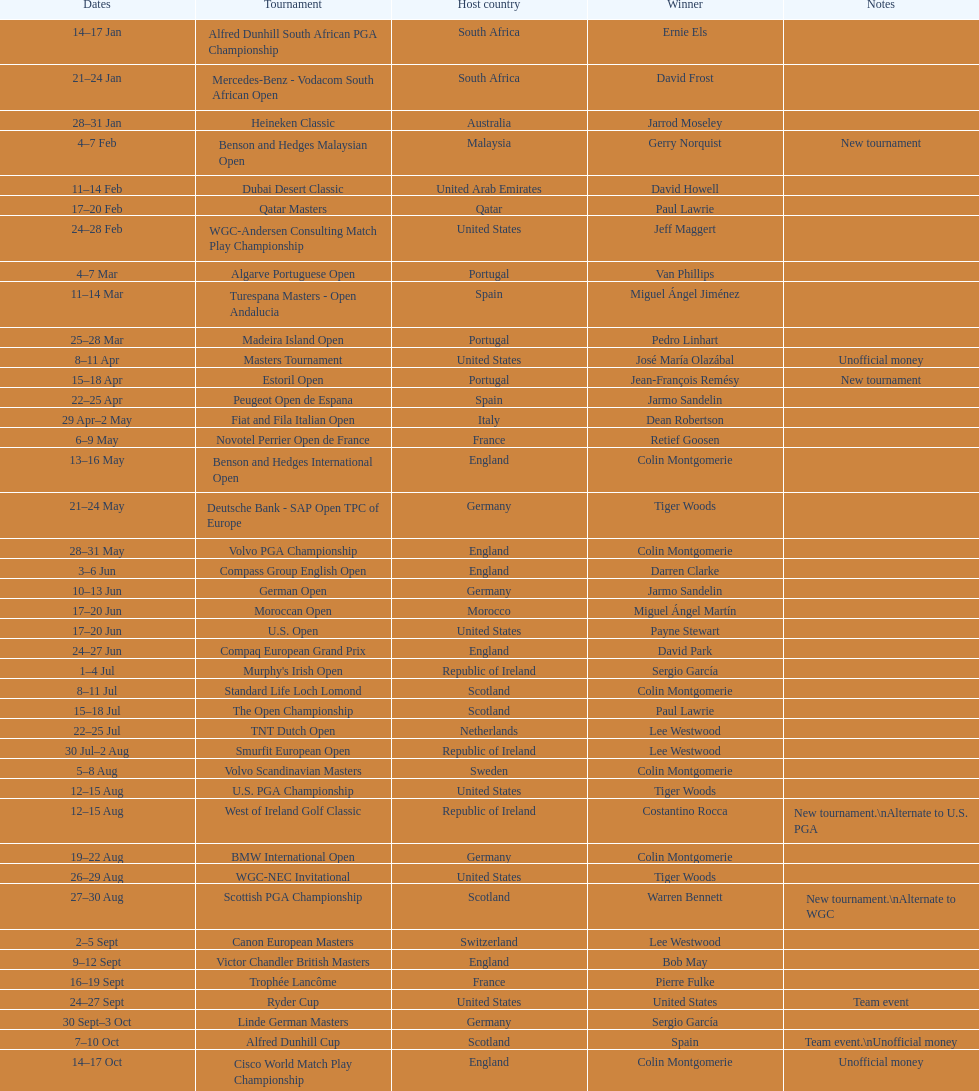Does any country have more than 5 winners? Yes. Can you give me this table as a dict? {'header': ['Dates', 'Tournament', 'Host country', 'Winner', 'Notes'], 'rows': [['14–17\xa0Jan', 'Alfred Dunhill South African PGA Championship', 'South Africa', 'Ernie Els', ''], ['21–24\xa0Jan', 'Mercedes-Benz - Vodacom South African Open', 'South Africa', 'David Frost', ''], ['28–31\xa0Jan', 'Heineken Classic', 'Australia', 'Jarrod Moseley', ''], ['4–7\xa0Feb', 'Benson and Hedges Malaysian Open', 'Malaysia', 'Gerry Norquist', 'New tournament'], ['11–14\xa0Feb', 'Dubai Desert Classic', 'United Arab Emirates', 'David Howell', ''], ['17–20\xa0Feb', 'Qatar Masters', 'Qatar', 'Paul Lawrie', ''], ['24–28\xa0Feb', 'WGC-Andersen Consulting Match Play Championship', 'United States', 'Jeff Maggert', ''], ['4–7\xa0Mar', 'Algarve Portuguese Open', 'Portugal', 'Van Phillips', ''], ['11–14\xa0Mar', 'Turespana Masters - Open Andalucia', 'Spain', 'Miguel Ángel Jiménez', ''], ['25–28\xa0Mar', 'Madeira Island Open', 'Portugal', 'Pedro Linhart', ''], ['8–11\xa0Apr', 'Masters Tournament', 'United States', 'José María Olazábal', 'Unofficial money'], ['15–18\xa0Apr', 'Estoril Open', 'Portugal', 'Jean-François Remésy', 'New tournament'], ['22–25\xa0Apr', 'Peugeot Open de Espana', 'Spain', 'Jarmo Sandelin', ''], ['29\xa0Apr–2\xa0May', 'Fiat and Fila Italian Open', 'Italy', 'Dean Robertson', ''], ['6–9\xa0May', 'Novotel Perrier Open de France', 'France', 'Retief Goosen', ''], ['13–16\xa0May', 'Benson and Hedges International Open', 'England', 'Colin Montgomerie', ''], ['21–24\xa0May', 'Deutsche Bank - SAP Open TPC of Europe', 'Germany', 'Tiger Woods', ''], ['28–31\xa0May', 'Volvo PGA Championship', 'England', 'Colin Montgomerie', ''], ['3–6\xa0Jun', 'Compass Group English Open', 'England', 'Darren Clarke', ''], ['10–13\xa0Jun', 'German Open', 'Germany', 'Jarmo Sandelin', ''], ['17–20\xa0Jun', 'Moroccan Open', 'Morocco', 'Miguel Ángel Martín', ''], ['17–20\xa0Jun', 'U.S. Open', 'United States', 'Payne Stewart', ''], ['24–27\xa0Jun', 'Compaq European Grand Prix', 'England', 'David Park', ''], ['1–4\xa0Jul', "Murphy's Irish Open", 'Republic of Ireland', 'Sergio García', ''], ['8–11\xa0Jul', 'Standard Life Loch Lomond', 'Scotland', 'Colin Montgomerie', ''], ['15–18\xa0Jul', 'The Open Championship', 'Scotland', 'Paul Lawrie', ''], ['22–25\xa0Jul', 'TNT Dutch Open', 'Netherlands', 'Lee Westwood', ''], ['30\xa0Jul–2\xa0Aug', 'Smurfit European Open', 'Republic of Ireland', 'Lee Westwood', ''], ['5–8\xa0Aug', 'Volvo Scandinavian Masters', 'Sweden', 'Colin Montgomerie', ''], ['12–15\xa0Aug', 'U.S. PGA Championship', 'United States', 'Tiger Woods', ''], ['12–15\xa0Aug', 'West of Ireland Golf Classic', 'Republic of Ireland', 'Costantino Rocca', 'New tournament.\\nAlternate to U.S. PGA'], ['19–22\xa0Aug', 'BMW International Open', 'Germany', 'Colin Montgomerie', ''], ['26–29\xa0Aug', 'WGC-NEC Invitational', 'United States', 'Tiger Woods', ''], ['27–30\xa0Aug', 'Scottish PGA Championship', 'Scotland', 'Warren Bennett', 'New tournament.\\nAlternate to WGC'], ['2–5\xa0Sept', 'Canon European Masters', 'Switzerland', 'Lee Westwood', ''], ['9–12\xa0Sept', 'Victor Chandler British Masters', 'England', 'Bob May', ''], ['16–19\xa0Sept', 'Trophée Lancôme', 'France', 'Pierre Fulke', ''], ['24–27\xa0Sept', 'Ryder Cup', 'United States', 'United States', 'Team event'], ['30\xa0Sept–3\xa0Oct', 'Linde German Masters', 'Germany', 'Sergio García', ''], ['7–10\xa0Oct', 'Alfred Dunhill Cup', 'Scotland', 'Spain', 'Team event.\\nUnofficial money'], ['14–17\xa0Oct', 'Cisco World Match Play Championship', 'England', 'Colin Montgomerie', 'Unofficial money'], ['14–17\xa0Oct', 'Sarazen World Open', 'Spain', 'Thomas Bjørn', 'New tournament'], ['21–24\xa0Oct', 'Belgacom Open', 'Belgium', 'Robert Karlsson', ''], ['28–31\xa0Oct', 'Volvo Masters', 'Spain', 'Miguel Ángel Jiménez', ''], ['4–7\xa0Nov', 'WGC-American Express Championship', 'Spain', 'Tiger Woods', ''], ['18–21\xa0Nov', 'World Cup of Golf', 'Malaysia', 'United States', 'Team event.\\nUnofficial money']]} 